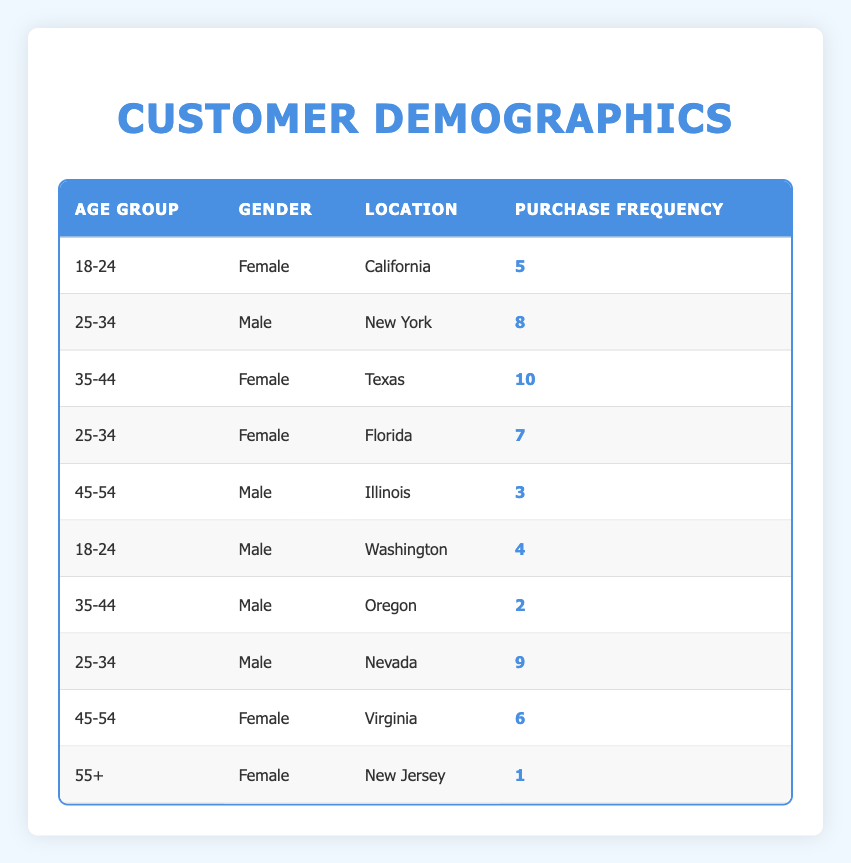What is the purchase frequency of the age group 35-44 for females? The table shows two entries for the age group 35-44, one for a female from Texas with a purchase frequency of 10. Thus, the answer is directly taken from this entry.
Answer: 10 Which gender has the highest purchase frequency, and what is that frequency? The highest purchase frequency in the table is 10, associated with the 35-44 year old female from Texas. There are no other entries with a higher value.
Answer: Female, 10 What is the total purchase frequency for the age group 25-34? There are three entries for the age group 25-34: Male from New York (8), Female from Florida (7), and Male from Nevada (9). Adding these gives 8 + 7 + 9 = 24.
Answer: 24 Is there a male customer in the age group 55+? There is no entry in the table for a male customer aged 55 or above, only a female aged 55+ from New Jersey is present. Therefore, the answer is no.
Answer: No What is the average purchase frequency for male customers across all age groups? The table shows purchase frequencies for male customers in three age groups: 25-34 (8 + 9), 35-44 (2), and 18-24 (4). The total purchase frequency for males is 8 + 9 + 2 + 4 = 23. Considering there are 4 entries, we compute 23/4 = 5.75.
Answer: 5.75 Which state has the highest purchase frequency for the age group 45-54? The table indicates two entries for the age group 45-54. One is a male from Illinois with a frequency of 3, and the other is a female from Virginia with a frequency of 6. The female from Virginia has the higher frequency of 6, making it the highest within this age group.
Answer: Virginia, 6 How many customers in the age group 18-24 made purchases? There are two entries in the age group 18-24: one female from California (5) and one male from Washington (4). Therefore, the total number of customers in this group is 2.
Answer: 2 What is the total purchase frequency for customers from California? According to the table, there is one entry for a female in California with a purchase frequency of 5. Therefore, the total frequency for customers from California is simply this value.
Answer: 5 